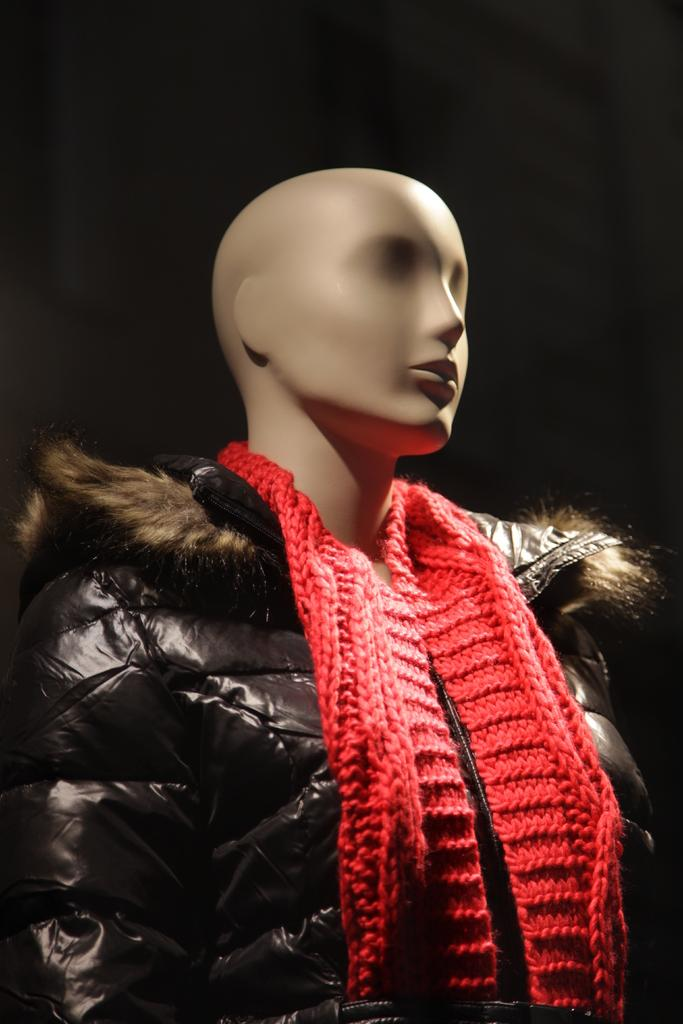What is the main subject of the picture? The main subject of the picture is a miniature statue. What is the statue wearing on its upper body? The statue is wearing a black jacket. What is the statue wearing around its neck? The statue is wearing a red muffler around its neck. What color is the background of the image? The background of the image is black. What type of attraction can be seen in the background of the image? There is no attraction visible in the background of the image; the background is black. How many kittens are sitting on the statue's head in the image? There are no kittens present in the image. 